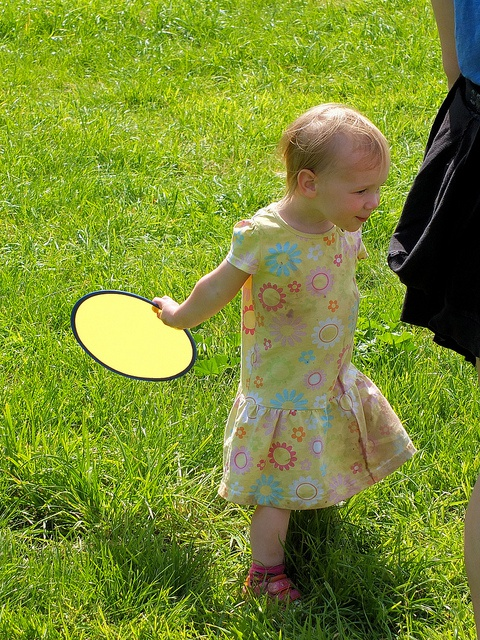Describe the objects in this image and their specific colors. I can see people in olive and gray tones, people in olive, black, gray, and darkblue tones, and frisbee in olive, khaki, black, and navy tones in this image. 